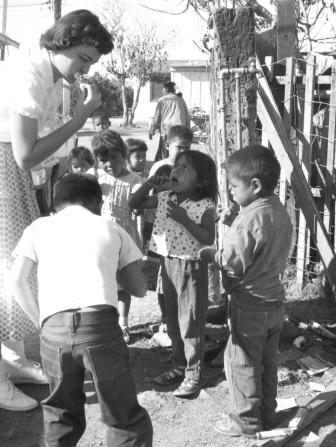Are these children in a school room?
Concise answer only. No. How many adults are shown?
Short answer required. 2. Is there a fence?
Short answer required. Yes. 